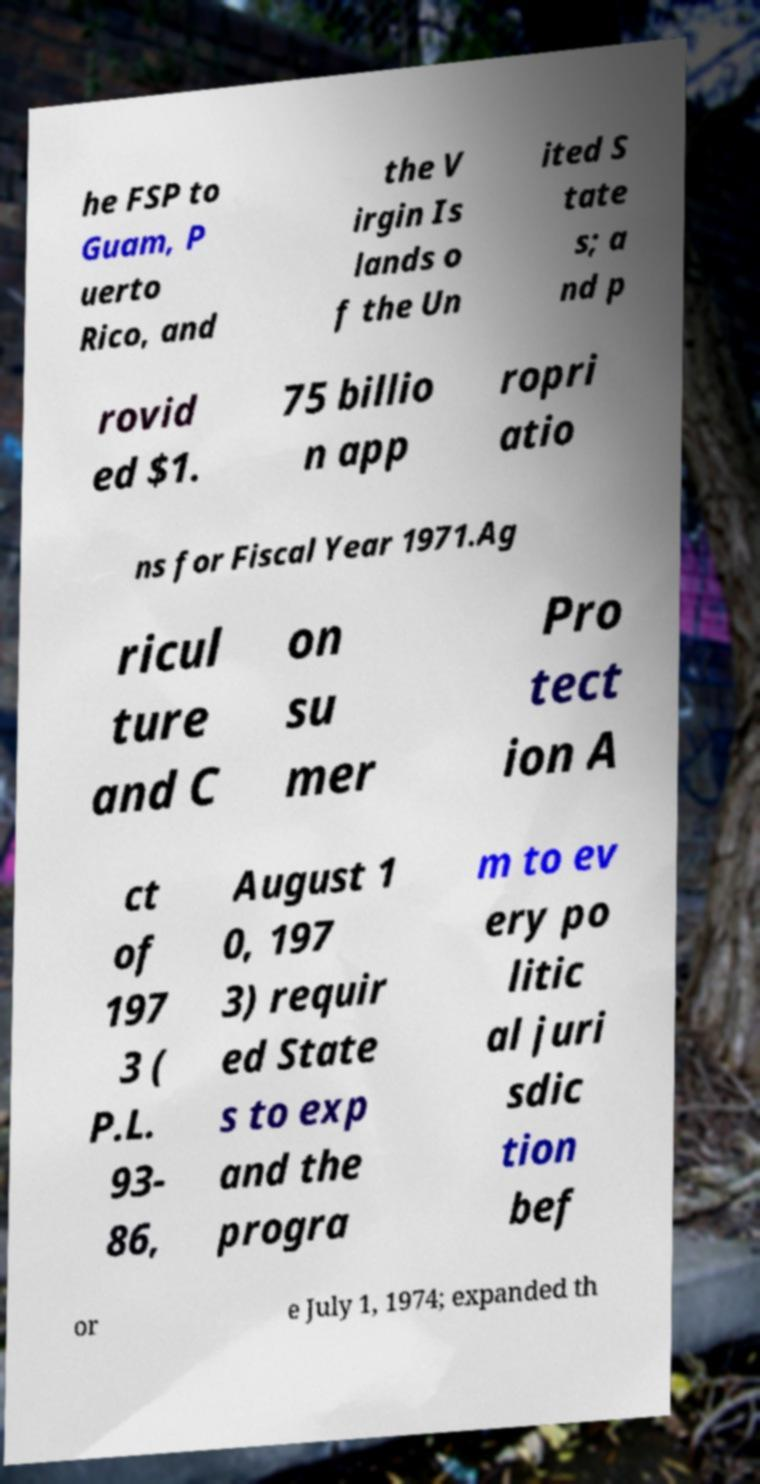Please identify and transcribe the text found in this image. he FSP to Guam, P uerto Rico, and the V irgin Is lands o f the Un ited S tate s; a nd p rovid ed $1. 75 billio n app ropri atio ns for Fiscal Year 1971.Ag ricul ture and C on su mer Pro tect ion A ct of 197 3 ( P.L. 93- 86, August 1 0, 197 3) requir ed State s to exp and the progra m to ev ery po litic al juri sdic tion bef or e July 1, 1974; expanded th 